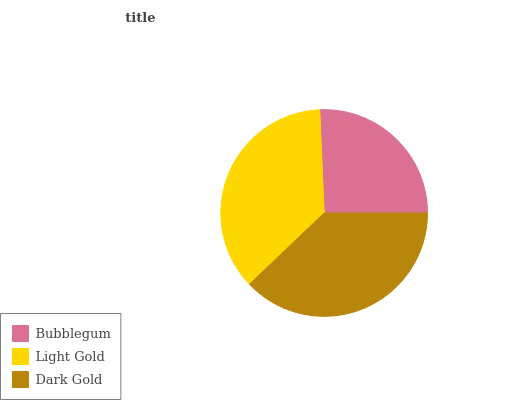Is Bubblegum the minimum?
Answer yes or no. Yes. Is Dark Gold the maximum?
Answer yes or no. Yes. Is Light Gold the minimum?
Answer yes or no. No. Is Light Gold the maximum?
Answer yes or no. No. Is Light Gold greater than Bubblegum?
Answer yes or no. Yes. Is Bubblegum less than Light Gold?
Answer yes or no. Yes. Is Bubblegum greater than Light Gold?
Answer yes or no. No. Is Light Gold less than Bubblegum?
Answer yes or no. No. Is Light Gold the high median?
Answer yes or no. Yes. Is Light Gold the low median?
Answer yes or no. Yes. Is Bubblegum the high median?
Answer yes or no. No. Is Bubblegum the low median?
Answer yes or no. No. 